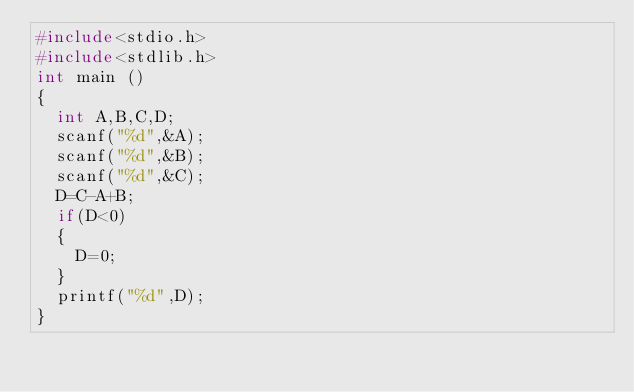<code> <loc_0><loc_0><loc_500><loc_500><_C_>#include<stdio.h>
#include<stdlib.h>
int main ()
{
  int A,B,C,D;
  scanf("%d",&A);
  scanf("%d",&B);
  scanf("%d",&C);
  D=C-A+B;
  if(D<0)
  {
    D=0;
  }
  printf("%d",D);
}
</code> 